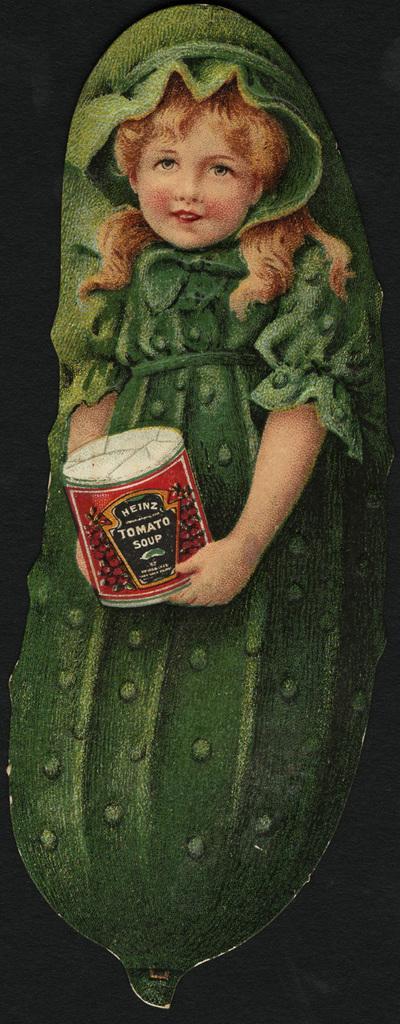Describe this image in one or two sentences. In the center of this picture we can see a painting of an object which seems to be the cucumber on which we can see the painting of a girl holding a box and we can see the text on the box. 